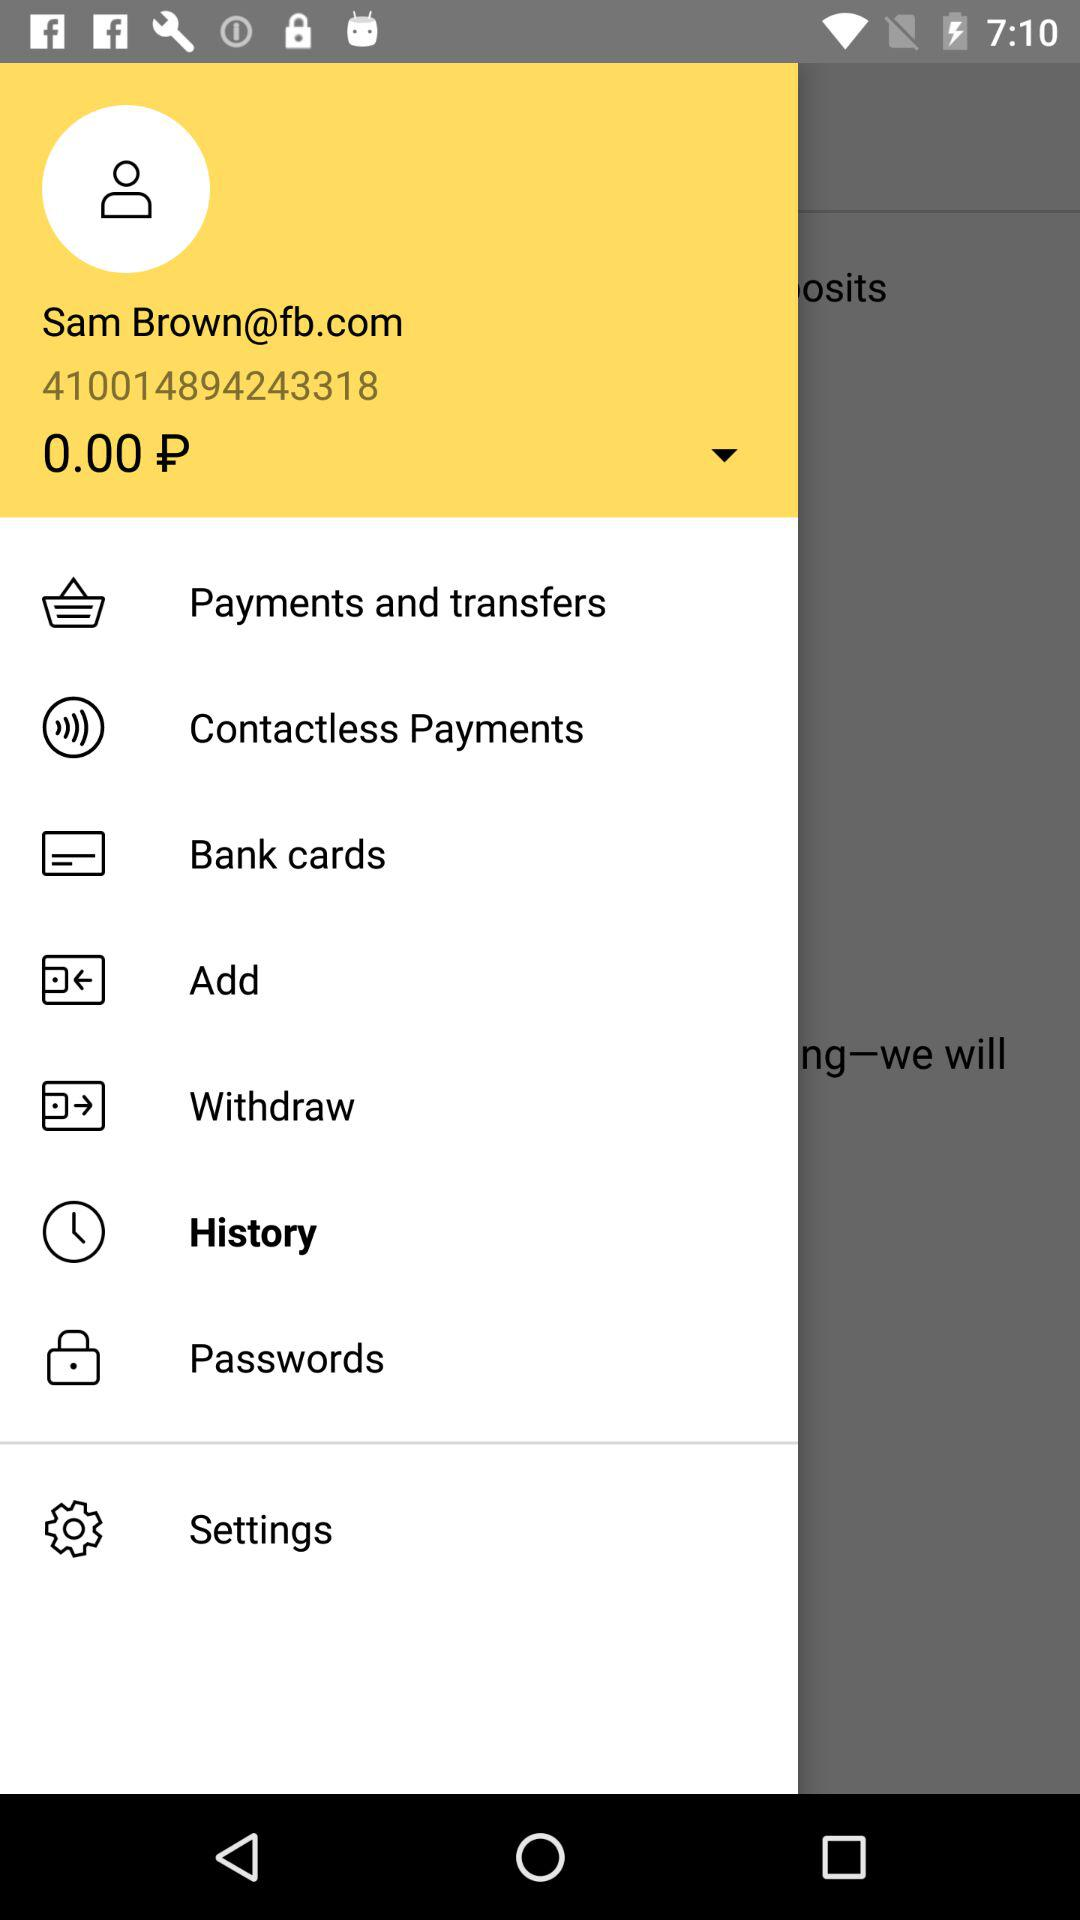How much money do I have in my account?
Answer the question using a single word or phrase. 0.00 P 